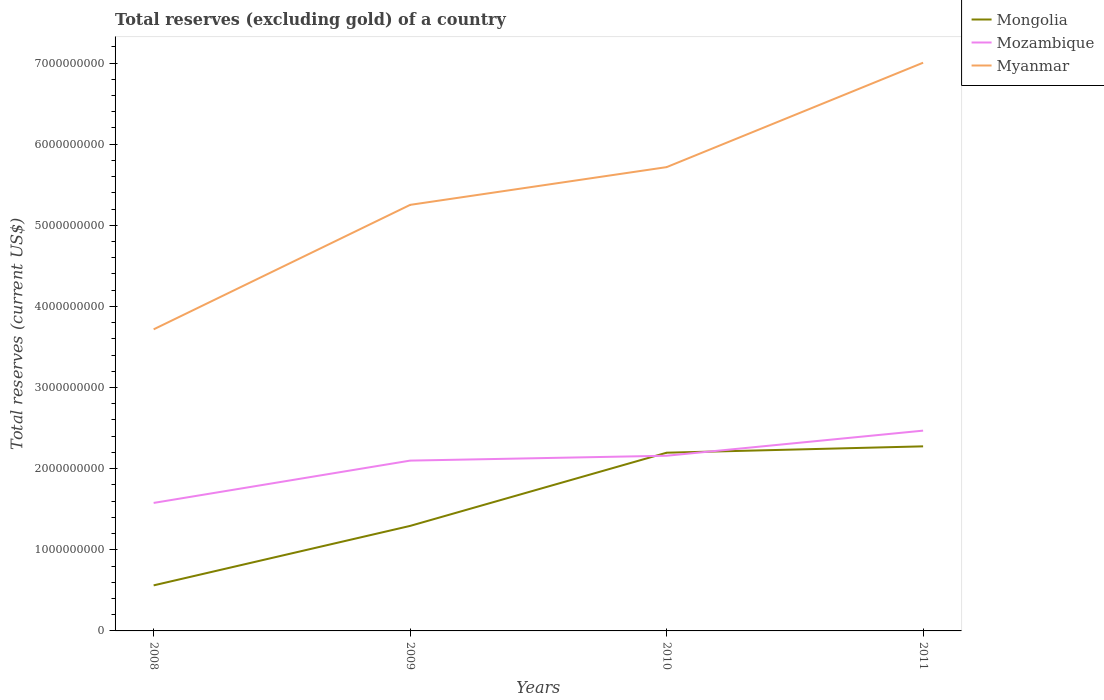Across all years, what is the maximum total reserves (excluding gold) in Mongolia?
Offer a terse response. 5.61e+08. In which year was the total reserves (excluding gold) in Myanmar maximum?
Make the answer very short. 2008. What is the total total reserves (excluding gold) in Mozambique in the graph?
Provide a short and direct response. -6.01e+07. What is the difference between the highest and the second highest total reserves (excluding gold) in Myanmar?
Offer a very short reply. 3.29e+09. How many lines are there?
Ensure brevity in your answer.  3. What is the difference between two consecutive major ticks on the Y-axis?
Your answer should be very brief. 1.00e+09. Does the graph contain any zero values?
Your answer should be very brief. No. Where does the legend appear in the graph?
Make the answer very short. Top right. How many legend labels are there?
Your answer should be compact. 3. What is the title of the graph?
Provide a short and direct response. Total reserves (excluding gold) of a country. Does "Tuvalu" appear as one of the legend labels in the graph?
Your answer should be very brief. No. What is the label or title of the X-axis?
Your response must be concise. Years. What is the label or title of the Y-axis?
Your answer should be very brief. Total reserves (current US$). What is the Total reserves (current US$) of Mongolia in 2008?
Give a very brief answer. 5.61e+08. What is the Total reserves (current US$) of Mozambique in 2008?
Your answer should be very brief. 1.58e+09. What is the Total reserves (current US$) of Myanmar in 2008?
Make the answer very short. 3.72e+09. What is the Total reserves (current US$) of Mongolia in 2009?
Provide a short and direct response. 1.29e+09. What is the Total reserves (current US$) of Mozambique in 2009?
Make the answer very short. 2.10e+09. What is the Total reserves (current US$) of Myanmar in 2009?
Provide a succinct answer. 5.25e+09. What is the Total reserves (current US$) in Mongolia in 2010?
Give a very brief answer. 2.20e+09. What is the Total reserves (current US$) in Mozambique in 2010?
Offer a very short reply. 2.16e+09. What is the Total reserves (current US$) in Myanmar in 2010?
Ensure brevity in your answer.  5.72e+09. What is the Total reserves (current US$) of Mongolia in 2011?
Offer a terse response. 2.28e+09. What is the Total reserves (current US$) of Mozambique in 2011?
Provide a succinct answer. 2.47e+09. What is the Total reserves (current US$) in Myanmar in 2011?
Your answer should be compact. 7.00e+09. Across all years, what is the maximum Total reserves (current US$) of Mongolia?
Your answer should be very brief. 2.28e+09. Across all years, what is the maximum Total reserves (current US$) of Mozambique?
Give a very brief answer. 2.47e+09. Across all years, what is the maximum Total reserves (current US$) in Myanmar?
Your answer should be very brief. 7.00e+09. Across all years, what is the minimum Total reserves (current US$) in Mongolia?
Ensure brevity in your answer.  5.61e+08. Across all years, what is the minimum Total reserves (current US$) of Mozambique?
Ensure brevity in your answer.  1.58e+09. Across all years, what is the minimum Total reserves (current US$) of Myanmar?
Your answer should be very brief. 3.72e+09. What is the total Total reserves (current US$) of Mongolia in the graph?
Provide a short and direct response. 6.33e+09. What is the total Total reserves (current US$) in Mozambique in the graph?
Provide a succinct answer. 8.31e+09. What is the total Total reserves (current US$) in Myanmar in the graph?
Make the answer very short. 2.17e+1. What is the difference between the Total reserves (current US$) of Mongolia in 2008 and that in 2009?
Your answer should be compact. -7.33e+08. What is the difference between the Total reserves (current US$) of Mozambique in 2008 and that in 2009?
Give a very brief answer. -5.22e+08. What is the difference between the Total reserves (current US$) of Myanmar in 2008 and that in 2009?
Ensure brevity in your answer.  -1.53e+09. What is the difference between the Total reserves (current US$) of Mongolia in 2008 and that in 2010?
Keep it short and to the point. -1.64e+09. What is the difference between the Total reserves (current US$) of Mozambique in 2008 and that in 2010?
Provide a succinct answer. -5.82e+08. What is the difference between the Total reserves (current US$) in Myanmar in 2008 and that in 2010?
Ensure brevity in your answer.  -2.00e+09. What is the difference between the Total reserves (current US$) of Mongolia in 2008 and that in 2011?
Offer a terse response. -1.71e+09. What is the difference between the Total reserves (current US$) in Mozambique in 2008 and that in 2011?
Provide a short and direct response. -8.91e+08. What is the difference between the Total reserves (current US$) in Myanmar in 2008 and that in 2011?
Ensure brevity in your answer.  -3.29e+09. What is the difference between the Total reserves (current US$) in Mongolia in 2009 and that in 2010?
Keep it short and to the point. -9.02e+08. What is the difference between the Total reserves (current US$) in Mozambique in 2009 and that in 2010?
Provide a short and direct response. -6.01e+07. What is the difference between the Total reserves (current US$) in Myanmar in 2009 and that in 2010?
Give a very brief answer. -4.65e+08. What is the difference between the Total reserves (current US$) in Mongolia in 2009 and that in 2011?
Keep it short and to the point. -9.81e+08. What is the difference between the Total reserves (current US$) of Mozambique in 2009 and that in 2011?
Your answer should be very brief. -3.70e+08. What is the difference between the Total reserves (current US$) in Myanmar in 2009 and that in 2011?
Keep it short and to the point. -1.75e+09. What is the difference between the Total reserves (current US$) in Mongolia in 2010 and that in 2011?
Make the answer very short. -7.85e+07. What is the difference between the Total reserves (current US$) in Mozambique in 2010 and that in 2011?
Make the answer very short. -3.09e+08. What is the difference between the Total reserves (current US$) of Myanmar in 2010 and that in 2011?
Keep it short and to the point. -1.29e+09. What is the difference between the Total reserves (current US$) in Mongolia in 2008 and the Total reserves (current US$) in Mozambique in 2009?
Offer a terse response. -1.54e+09. What is the difference between the Total reserves (current US$) in Mongolia in 2008 and the Total reserves (current US$) in Myanmar in 2009?
Give a very brief answer. -4.69e+09. What is the difference between the Total reserves (current US$) in Mozambique in 2008 and the Total reserves (current US$) in Myanmar in 2009?
Give a very brief answer. -3.67e+09. What is the difference between the Total reserves (current US$) of Mongolia in 2008 and the Total reserves (current US$) of Mozambique in 2010?
Provide a short and direct response. -1.60e+09. What is the difference between the Total reserves (current US$) of Mongolia in 2008 and the Total reserves (current US$) of Myanmar in 2010?
Give a very brief answer. -5.16e+09. What is the difference between the Total reserves (current US$) of Mozambique in 2008 and the Total reserves (current US$) of Myanmar in 2010?
Ensure brevity in your answer.  -4.14e+09. What is the difference between the Total reserves (current US$) in Mongolia in 2008 and the Total reserves (current US$) in Mozambique in 2011?
Provide a short and direct response. -1.91e+09. What is the difference between the Total reserves (current US$) of Mongolia in 2008 and the Total reserves (current US$) of Myanmar in 2011?
Give a very brief answer. -6.44e+09. What is the difference between the Total reserves (current US$) of Mozambique in 2008 and the Total reserves (current US$) of Myanmar in 2011?
Ensure brevity in your answer.  -5.43e+09. What is the difference between the Total reserves (current US$) in Mongolia in 2009 and the Total reserves (current US$) in Mozambique in 2010?
Offer a terse response. -8.65e+08. What is the difference between the Total reserves (current US$) in Mongolia in 2009 and the Total reserves (current US$) in Myanmar in 2010?
Keep it short and to the point. -4.42e+09. What is the difference between the Total reserves (current US$) in Mozambique in 2009 and the Total reserves (current US$) in Myanmar in 2010?
Offer a very short reply. -3.62e+09. What is the difference between the Total reserves (current US$) of Mongolia in 2009 and the Total reserves (current US$) of Mozambique in 2011?
Give a very brief answer. -1.17e+09. What is the difference between the Total reserves (current US$) in Mongolia in 2009 and the Total reserves (current US$) in Myanmar in 2011?
Give a very brief answer. -5.71e+09. What is the difference between the Total reserves (current US$) in Mozambique in 2009 and the Total reserves (current US$) in Myanmar in 2011?
Your response must be concise. -4.90e+09. What is the difference between the Total reserves (current US$) of Mongolia in 2010 and the Total reserves (current US$) of Mozambique in 2011?
Provide a succinct answer. -2.72e+08. What is the difference between the Total reserves (current US$) of Mongolia in 2010 and the Total reserves (current US$) of Myanmar in 2011?
Your answer should be very brief. -4.81e+09. What is the difference between the Total reserves (current US$) of Mozambique in 2010 and the Total reserves (current US$) of Myanmar in 2011?
Ensure brevity in your answer.  -4.84e+09. What is the average Total reserves (current US$) in Mongolia per year?
Offer a terse response. 1.58e+09. What is the average Total reserves (current US$) in Mozambique per year?
Make the answer very short. 2.08e+09. What is the average Total reserves (current US$) in Myanmar per year?
Give a very brief answer. 5.42e+09. In the year 2008, what is the difference between the Total reserves (current US$) in Mongolia and Total reserves (current US$) in Mozambique?
Give a very brief answer. -1.02e+09. In the year 2008, what is the difference between the Total reserves (current US$) in Mongolia and Total reserves (current US$) in Myanmar?
Give a very brief answer. -3.16e+09. In the year 2008, what is the difference between the Total reserves (current US$) of Mozambique and Total reserves (current US$) of Myanmar?
Your response must be concise. -2.14e+09. In the year 2009, what is the difference between the Total reserves (current US$) of Mongolia and Total reserves (current US$) of Mozambique?
Ensure brevity in your answer.  -8.05e+08. In the year 2009, what is the difference between the Total reserves (current US$) of Mongolia and Total reserves (current US$) of Myanmar?
Your response must be concise. -3.96e+09. In the year 2009, what is the difference between the Total reserves (current US$) of Mozambique and Total reserves (current US$) of Myanmar?
Offer a terse response. -3.15e+09. In the year 2010, what is the difference between the Total reserves (current US$) in Mongolia and Total reserves (current US$) in Mozambique?
Ensure brevity in your answer.  3.73e+07. In the year 2010, what is the difference between the Total reserves (current US$) in Mongolia and Total reserves (current US$) in Myanmar?
Your answer should be very brief. -3.52e+09. In the year 2010, what is the difference between the Total reserves (current US$) in Mozambique and Total reserves (current US$) in Myanmar?
Provide a short and direct response. -3.56e+09. In the year 2011, what is the difference between the Total reserves (current US$) of Mongolia and Total reserves (current US$) of Mozambique?
Provide a succinct answer. -1.94e+08. In the year 2011, what is the difference between the Total reserves (current US$) of Mongolia and Total reserves (current US$) of Myanmar?
Provide a short and direct response. -4.73e+09. In the year 2011, what is the difference between the Total reserves (current US$) of Mozambique and Total reserves (current US$) of Myanmar?
Your response must be concise. -4.54e+09. What is the ratio of the Total reserves (current US$) of Mongolia in 2008 to that in 2009?
Give a very brief answer. 0.43. What is the ratio of the Total reserves (current US$) in Mozambique in 2008 to that in 2009?
Offer a very short reply. 0.75. What is the ratio of the Total reserves (current US$) in Myanmar in 2008 to that in 2009?
Offer a terse response. 0.71. What is the ratio of the Total reserves (current US$) in Mongolia in 2008 to that in 2010?
Keep it short and to the point. 0.26. What is the ratio of the Total reserves (current US$) in Mozambique in 2008 to that in 2010?
Keep it short and to the point. 0.73. What is the ratio of the Total reserves (current US$) in Myanmar in 2008 to that in 2010?
Your answer should be compact. 0.65. What is the ratio of the Total reserves (current US$) of Mongolia in 2008 to that in 2011?
Give a very brief answer. 0.25. What is the ratio of the Total reserves (current US$) in Mozambique in 2008 to that in 2011?
Give a very brief answer. 0.64. What is the ratio of the Total reserves (current US$) of Myanmar in 2008 to that in 2011?
Your answer should be very brief. 0.53. What is the ratio of the Total reserves (current US$) in Mongolia in 2009 to that in 2010?
Offer a very short reply. 0.59. What is the ratio of the Total reserves (current US$) of Mozambique in 2009 to that in 2010?
Provide a succinct answer. 0.97. What is the ratio of the Total reserves (current US$) of Myanmar in 2009 to that in 2010?
Provide a succinct answer. 0.92. What is the ratio of the Total reserves (current US$) of Mongolia in 2009 to that in 2011?
Keep it short and to the point. 0.57. What is the ratio of the Total reserves (current US$) in Mozambique in 2009 to that in 2011?
Offer a very short reply. 0.85. What is the ratio of the Total reserves (current US$) in Myanmar in 2009 to that in 2011?
Your answer should be compact. 0.75. What is the ratio of the Total reserves (current US$) in Mongolia in 2010 to that in 2011?
Give a very brief answer. 0.97. What is the ratio of the Total reserves (current US$) in Mozambique in 2010 to that in 2011?
Keep it short and to the point. 0.87. What is the ratio of the Total reserves (current US$) of Myanmar in 2010 to that in 2011?
Make the answer very short. 0.82. What is the difference between the highest and the second highest Total reserves (current US$) of Mongolia?
Your answer should be compact. 7.85e+07. What is the difference between the highest and the second highest Total reserves (current US$) in Mozambique?
Offer a very short reply. 3.09e+08. What is the difference between the highest and the second highest Total reserves (current US$) of Myanmar?
Offer a very short reply. 1.29e+09. What is the difference between the highest and the lowest Total reserves (current US$) of Mongolia?
Keep it short and to the point. 1.71e+09. What is the difference between the highest and the lowest Total reserves (current US$) of Mozambique?
Ensure brevity in your answer.  8.91e+08. What is the difference between the highest and the lowest Total reserves (current US$) of Myanmar?
Your answer should be very brief. 3.29e+09. 